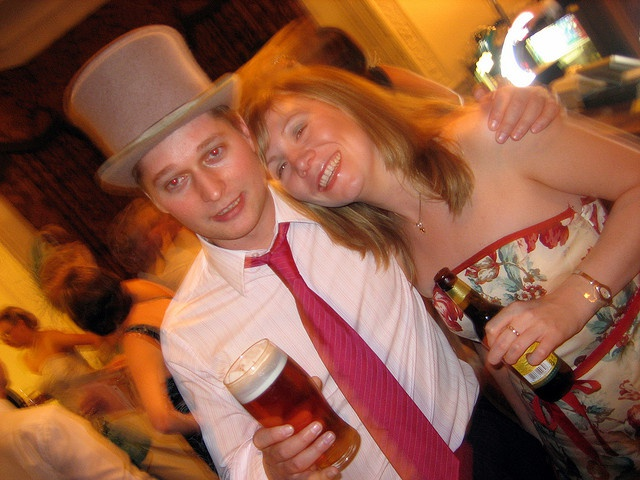Describe the objects in this image and their specific colors. I can see people in maroon, salmon, and brown tones, people in maroon, brown, pink, and black tones, tie in maroon and brown tones, people in maroon, black, red, and brown tones, and people in maroon, orange, and brown tones in this image. 